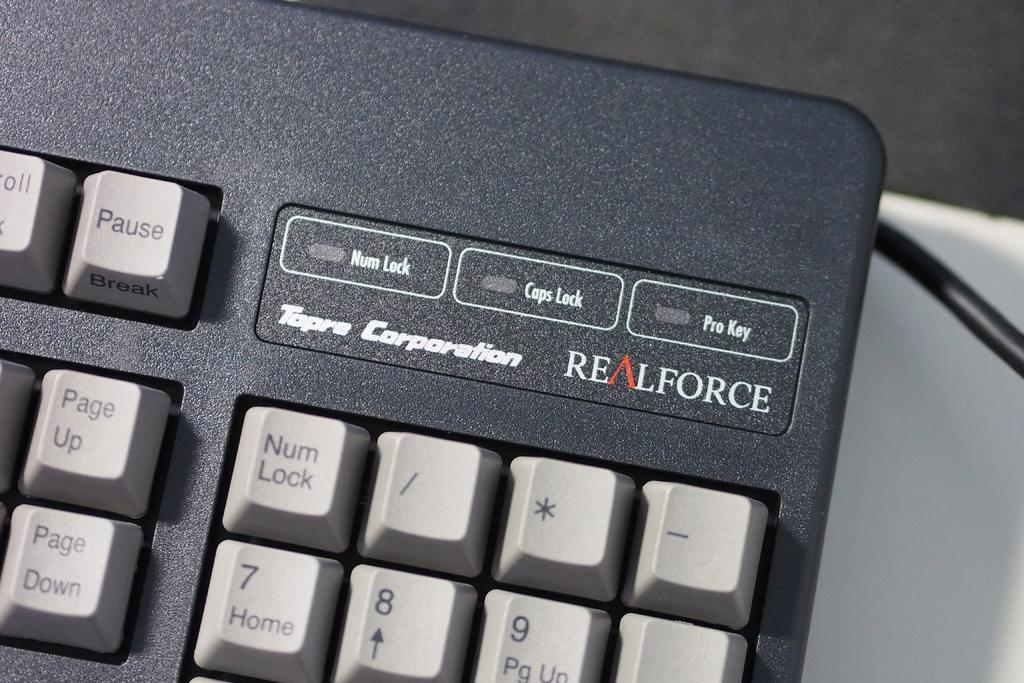Provide a one-sentence caption for the provided image. A close up of the top right hand corner of a realforce keyboard. 